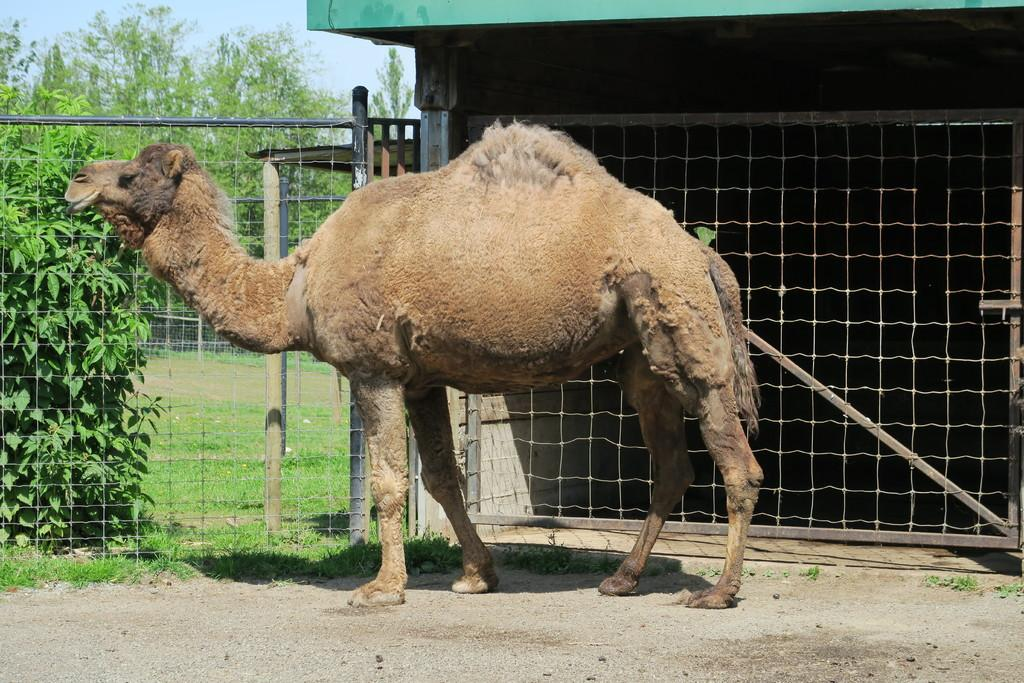What is the main subject in the center of the image? There is a camel in the center of the image. What can be seen in the background of the image? There is a fence, trees, plants, and a shelter in the background of the image. What is at the bottom of the image? There is a walkway and grass at the bottom of the image. What type of drug is the camel using in the image? There is no drug present in the image, and the camel is not using any drug. 